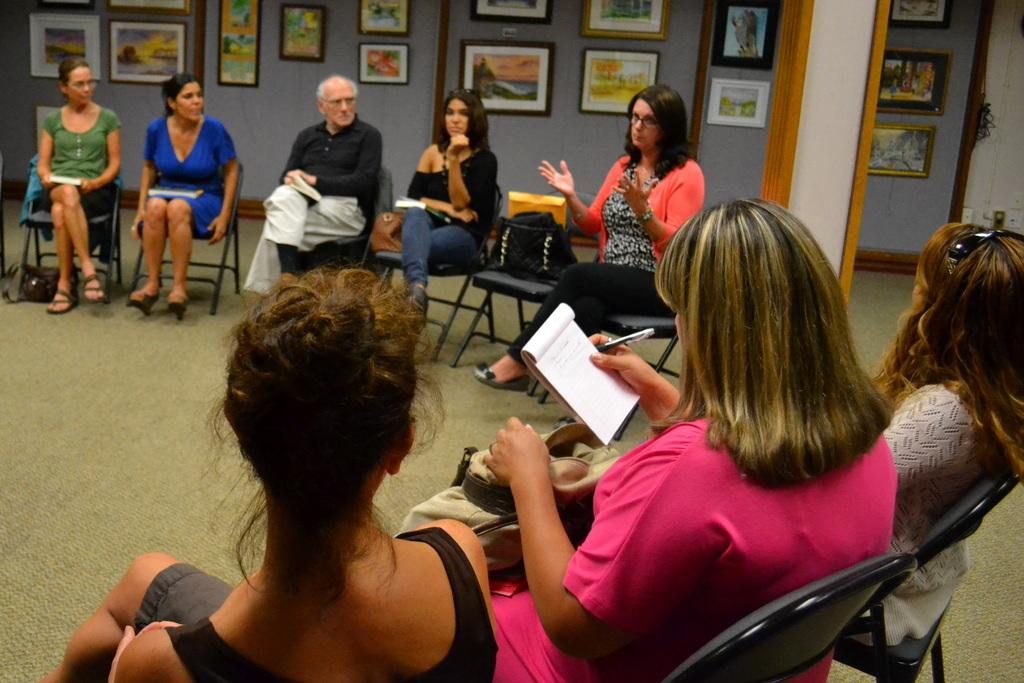What are the people in the image doing? The people in the image are sitting on chairs. What is at the bottom of the image? There is a carpet at the bottom of the image. What can be seen on the wall in the background of the image? There are photo frames on the wall in the background of the image. What type of liquid is being poured from the dolls in the image? There are no dolls or liquid present in the image. 